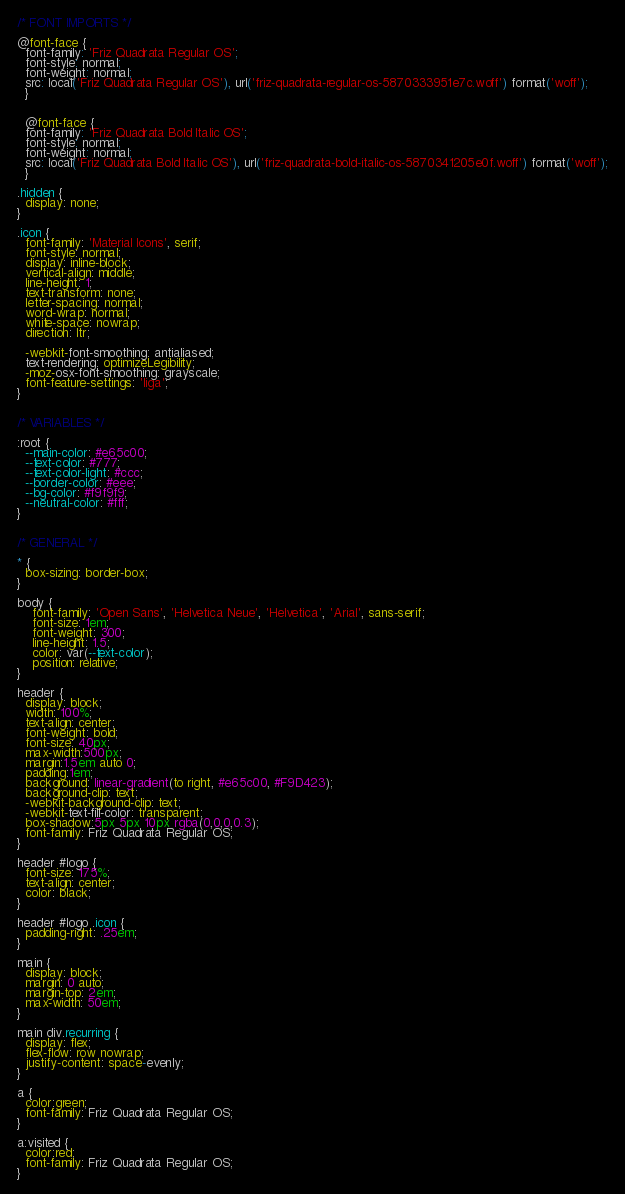<code> <loc_0><loc_0><loc_500><loc_500><_CSS_>
/* FONT IMPORTS */

@font-face {
  font-family: 'Friz Quadrata Regular OS';
  font-style: normal;
  font-weight: normal;
  src: local('Friz Quadrata Regular OS'), url('friz-quadrata-regular-os-5870333951e7c.woff') format('woff');
  }
  
  
  @font-face {
  font-family: 'Friz Quadrata Bold Italic OS';
  font-style: normal;
  font-weight: normal;
  src: local('Friz Quadrata Bold Italic OS'), url('friz-quadrata-bold-italic-os-5870341205e0f.woff') format('woff');
  }

.hidden {
  display: none;
}

.icon {
  font-family: 'Material Icons', serif;
  font-style: normal;
  display: inline-block;
  vertical-align: middle;
  line-height: 1;
  text-transform: none;
  letter-spacing: normal;
  word-wrap: normal;
  white-space: nowrap;
  direction: ltr;

  -webkit-font-smoothing: antialiased;
  text-rendering: optimizeLegibility;
  -moz-osx-font-smoothing: grayscale;
  font-feature-settings: 'liga';
}


/* VARIABLES */

:root {
  --main-color: #e65c00;
  --text-color: #777;
  --text-color-light: #ccc;
  --border-color: #eee;
  --bg-color: #f9f9f9;
  --neutral-color: #fff;
}


/* GENERAL */

* {
  box-sizing: border-box;
}

body {
    font-family: 'Open Sans', 'Helvetica Neue', 'Helvetica', 'Arial', sans-serif;
    font-size: 1em;
    font-weight: 300;
    line-height: 1.5;
    color: var(--text-color);
    position: relative;
}

header {
  display: block;
  width: 100%;
  text-align: center;
  font-weight: bold;
  font-size: 40px;
  max-width:500px;
  margin:1.5em auto 0;
  padding:1em;
  background: linear-gradient(to right, #e65c00, #F9D423);
  background-clip: text;
  -webkit-background-clip: text;
  -webkit-text-fill-color: transparent;
  box-shadow:5px 5px 10px rgba(0,0,0,0.3);
  font-family: Friz Quadrata Regular OS;
}

header #logo {
  font-size: 175%;
  text-align: center;
  color: black;
}

header #logo .icon {
  padding-right: .25em;
}

main {
  display: block;
  margin: 0 auto;
  margin-top: 2em;
  max-width: 50em;
}

main div.recurring {
  display: flex;
  flex-flow: row nowrap;
  justify-content: space-evenly;
}

a {
  color:green;
  font-family: Friz Quadrata Regular OS;
}

a:visited {
  color:red;
  font-family: Friz Quadrata Regular OS;
}</code> 